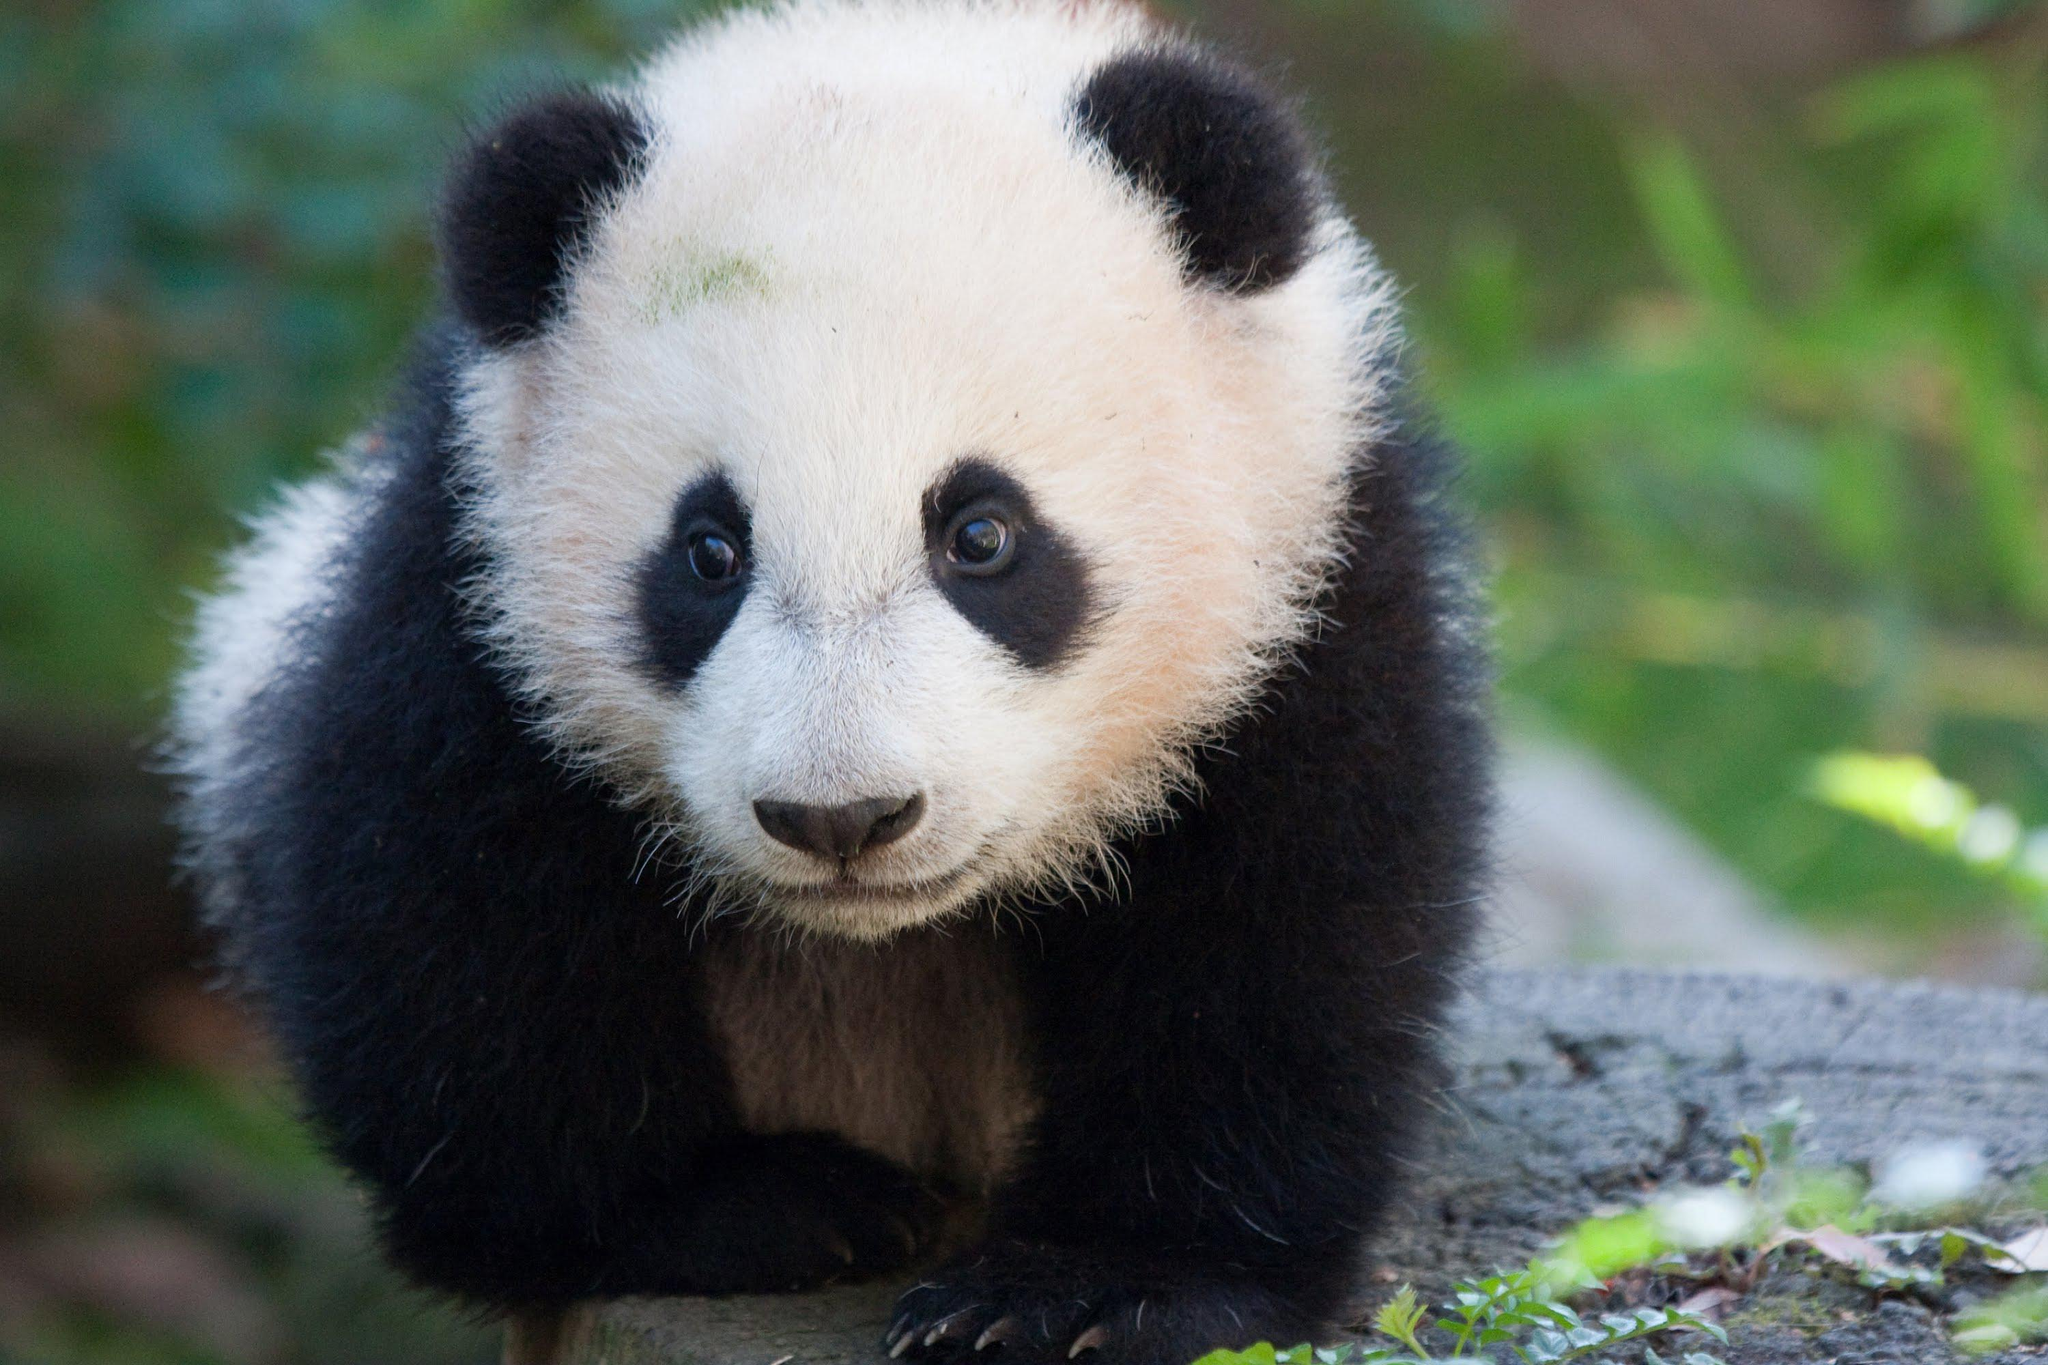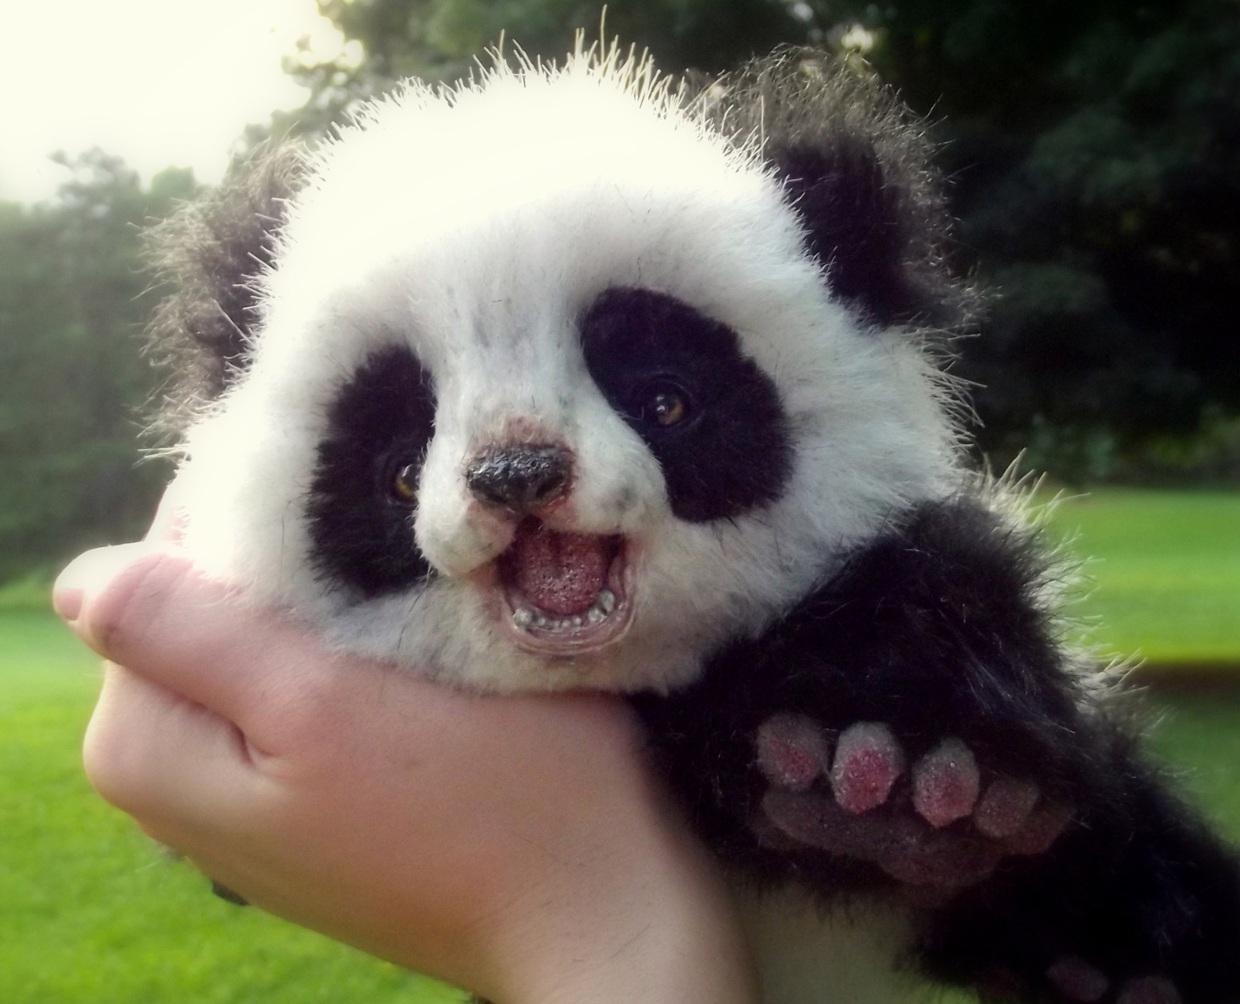The first image is the image on the left, the second image is the image on the right. Evaluate the accuracy of this statement regarding the images: "One panda image features an expanse of green lawn in the background.". Is it true? Answer yes or no. Yes. 